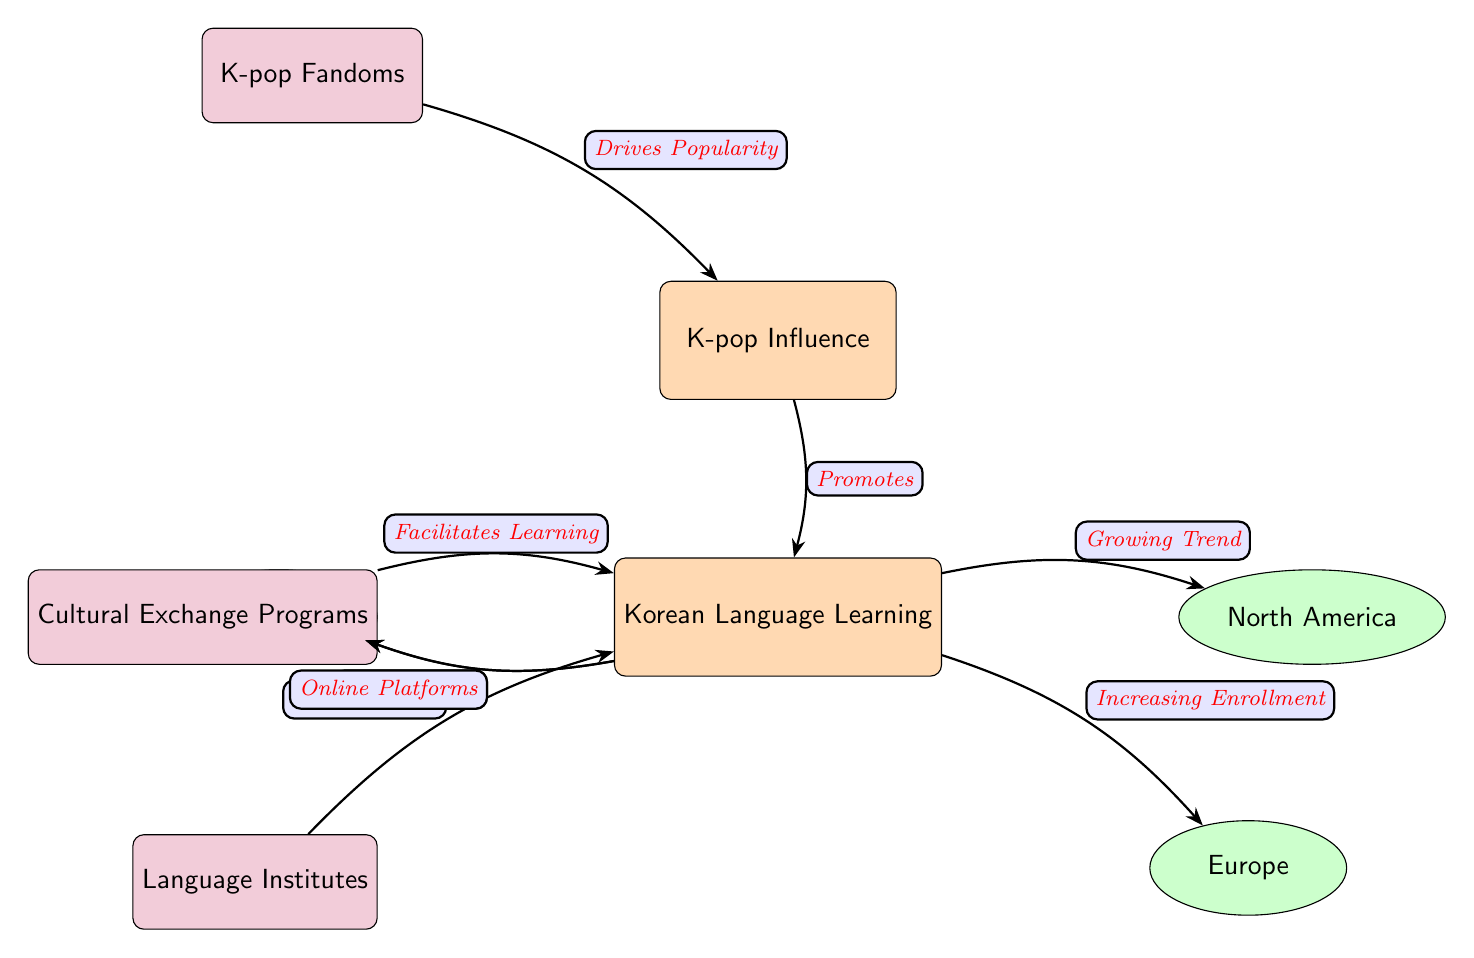What is the main influence in the diagram? The diagram identifies "K-pop Influence" as the primary factor at the top. This main node connects directly to Korean language learning, indicating its significance.
Answer: K-pop Influence How many regions are influenced by Korean language learning according to the diagram? The diagram shows three regions: Asia, North America, and Europe. Each is connected to the "Korean Language Learning" node, indicating their involvement.
Answer: 3 What type of programs facilitate learning in the context of Korean language? The diagram indicates "Cultural Exchange Programs" as a support node that facilitates learning, linking directly to the language learning node.
Answer: Cultural Exchange Programs What trend is observed in North America regarding Korean language learning? The arrow linking "Korean Language Learning" to "North America" is labeled "Growing Trend," suggesting an increasing interest in learning Korean in that region.
Answer: Growing Trend Which support node offers courses related to the Korean language? The node labeled "Language Institutes" directly connects to "Korean Language Learning," indicating their role in providing courses for learning the language.
Answer: Language Institutes How does K-pop fandom relate to K-pop influence? The diagram shows that "K-pop Fandoms" drive the popularity of K-pop, hence strengthening its influence on language learning. The flow is from fandoms to K-pop influence.
Answer: Drives Popularity What connection does online platforms have with Korean language learning? The diagram indicates that "Online Platforms" connect to "Korean Language Learning," suggesting that these platforms contribute to language education.
Answer: Online Platforms Which node is at the top of the diagram? The highest node in the diagram is "K-pop Influence," placed above all other nodes and indicating its overarching role.
Answer: K-pop Influence What is the relationship between language institutes and Korean language learning? The diagram shows a direct arrow from "Language Institutes" to "Korean Language Learning," indicating that institutes offer structured education for this purpose.
Answer: Offer Courses 